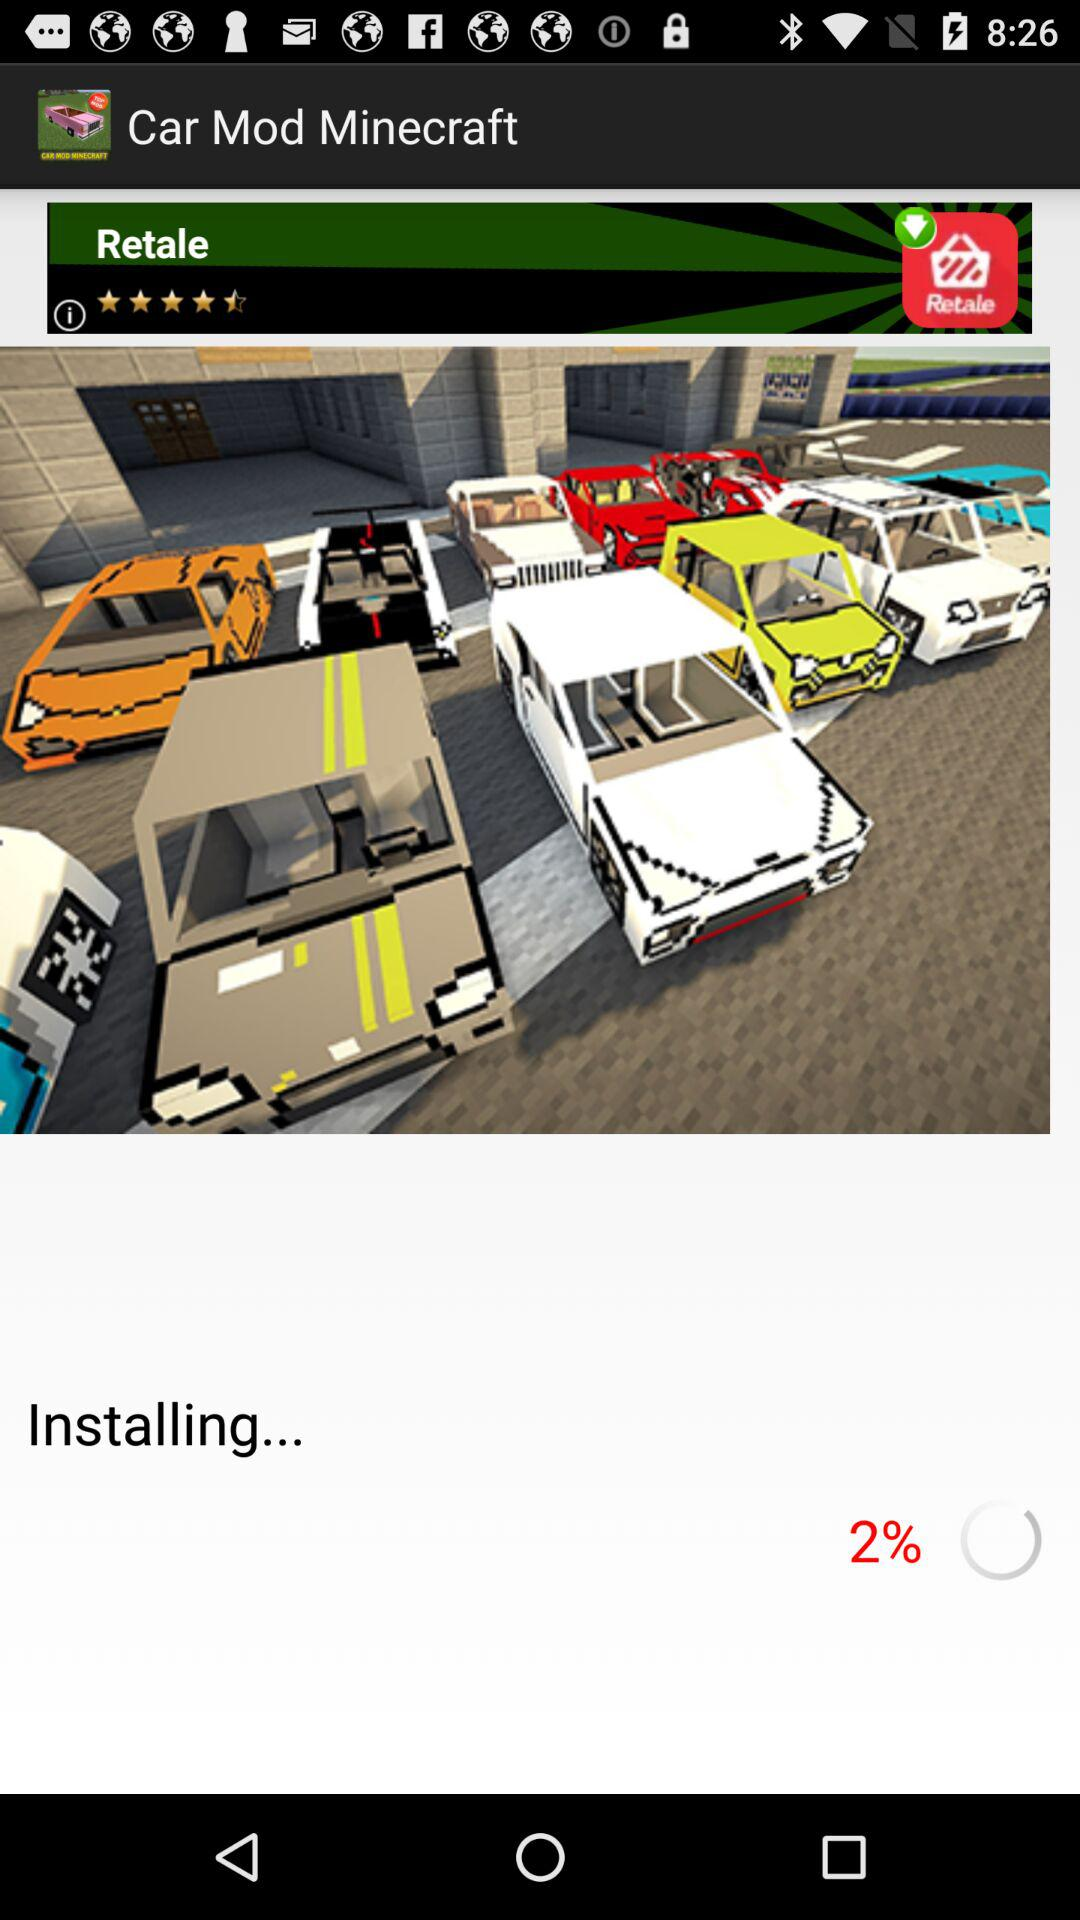What percentage of the installation is complete? The percentage of the installation that is complete is 2%. 